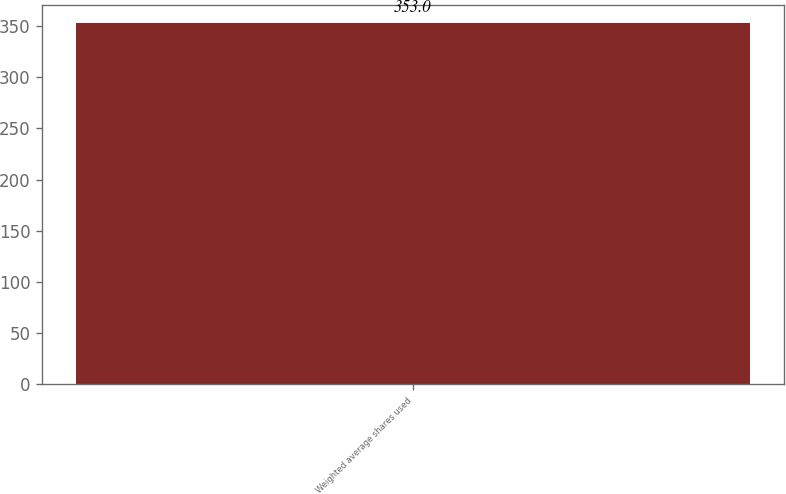Convert chart to OTSL. <chart><loc_0><loc_0><loc_500><loc_500><bar_chart><fcel>Weighted average shares used<nl><fcel>353<nl></chart> 